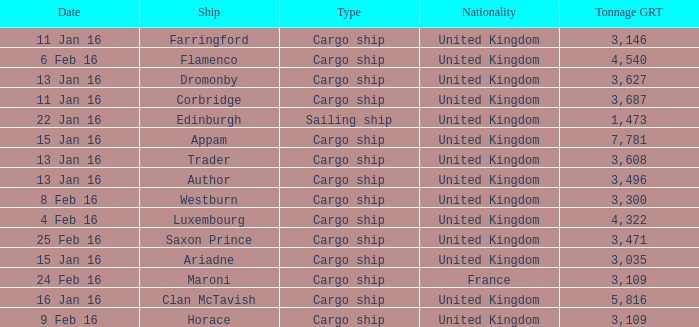What is the most tonnage grt of any ship sunk or captured on 16 jan 16? 5816.0. 